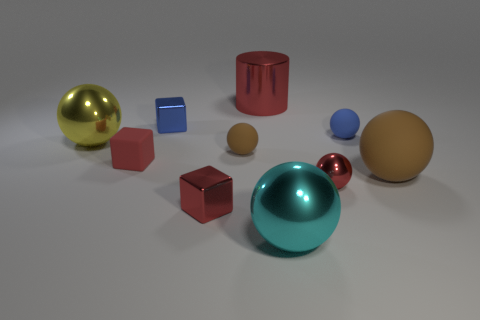Subtract all tiny brown rubber spheres. How many spheres are left? 5 Subtract all yellow balls. How many balls are left? 5 Subtract all yellow cubes. Subtract all purple balls. How many cubes are left? 3 Subtract all balls. How many objects are left? 4 Add 5 big balls. How many big balls are left? 8 Add 7 big purple rubber spheres. How many big purple rubber spheres exist? 7 Subtract 0 gray blocks. How many objects are left? 10 Subtract all red matte cubes. Subtract all big green metallic balls. How many objects are left? 9 